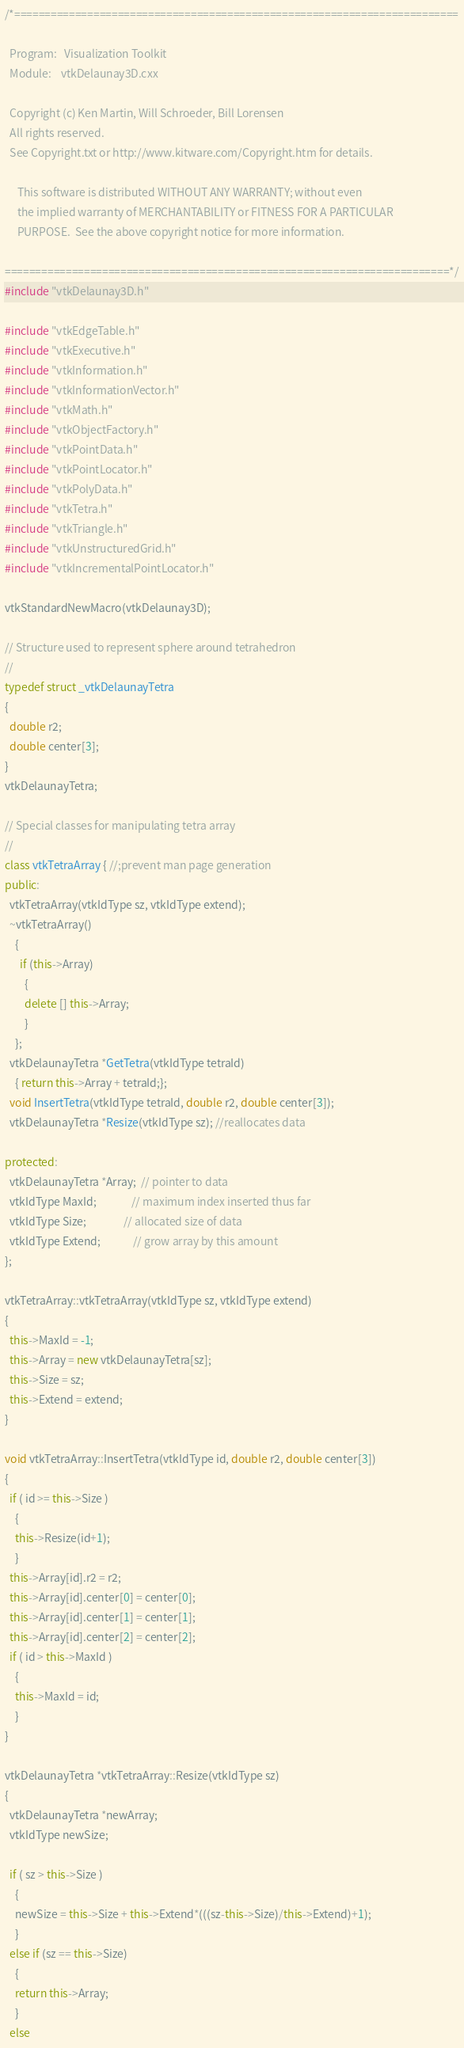<code> <loc_0><loc_0><loc_500><loc_500><_C++_>/*=========================================================================

  Program:   Visualization Toolkit
  Module:    vtkDelaunay3D.cxx

  Copyright (c) Ken Martin, Will Schroeder, Bill Lorensen
  All rights reserved.
  See Copyright.txt or http://www.kitware.com/Copyright.htm for details.

     This software is distributed WITHOUT ANY WARRANTY; without even
     the implied warranty of MERCHANTABILITY or FITNESS FOR A PARTICULAR
     PURPOSE.  See the above copyright notice for more information.

=========================================================================*/
#include "vtkDelaunay3D.h"

#include "vtkEdgeTable.h"
#include "vtkExecutive.h"
#include "vtkInformation.h"
#include "vtkInformationVector.h"
#include "vtkMath.h"
#include "vtkObjectFactory.h"
#include "vtkPointData.h"
#include "vtkPointLocator.h"
#include "vtkPolyData.h"
#include "vtkTetra.h"
#include "vtkTriangle.h"
#include "vtkUnstructuredGrid.h"
#include "vtkIncrementalPointLocator.h"

vtkStandardNewMacro(vtkDelaunay3D);

// Structure used to represent sphere around tetrahedron
//
typedef struct _vtkDelaunayTetra 
{
  double r2;
  double center[3];
}
vtkDelaunayTetra;

// Special classes for manipulating tetra array
//
class vtkTetraArray { //;prevent man page generation
public:
  vtkTetraArray(vtkIdType sz, vtkIdType extend);
  ~vtkTetraArray()
    {
      if (this->Array)
        {
        delete [] this->Array;
        }
    };
  vtkDelaunayTetra *GetTetra(vtkIdType tetraId) 
    { return this->Array + tetraId;};
  void InsertTetra(vtkIdType tetraId, double r2, double center[3]);
  vtkDelaunayTetra *Resize(vtkIdType sz); //reallocates data

protected:
  vtkDelaunayTetra *Array;  // pointer to data
  vtkIdType MaxId;              // maximum index inserted thus far
  vtkIdType Size;               // allocated size of data
  vtkIdType Extend;             // grow array by this amount
};

vtkTetraArray::vtkTetraArray(vtkIdType sz, vtkIdType extend)
{
  this->MaxId = -1; 
  this->Array = new vtkDelaunayTetra[sz];
  this->Size = sz;
  this->Extend = extend;
}

void vtkTetraArray::InsertTetra(vtkIdType id, double r2, double center[3])
{
  if ( id >= this->Size )
    {
    this->Resize(id+1);
    }
  this->Array[id].r2 = r2;
  this->Array[id].center[0] = center[0];
  this->Array[id].center[1] = center[1];
  this->Array[id].center[2] = center[2];
  if ( id > this->MaxId )
    {
    this->MaxId = id;
    }
}

vtkDelaunayTetra *vtkTetraArray::Resize(vtkIdType sz)
{
  vtkDelaunayTetra *newArray;
  vtkIdType newSize;

  if ( sz > this->Size )
    {
    newSize = this->Size + this->Extend*(((sz-this->Size)/this->Extend)+1);
    }
  else if (sz == this->Size)
    {
    return this->Array;
    }
  else</code> 